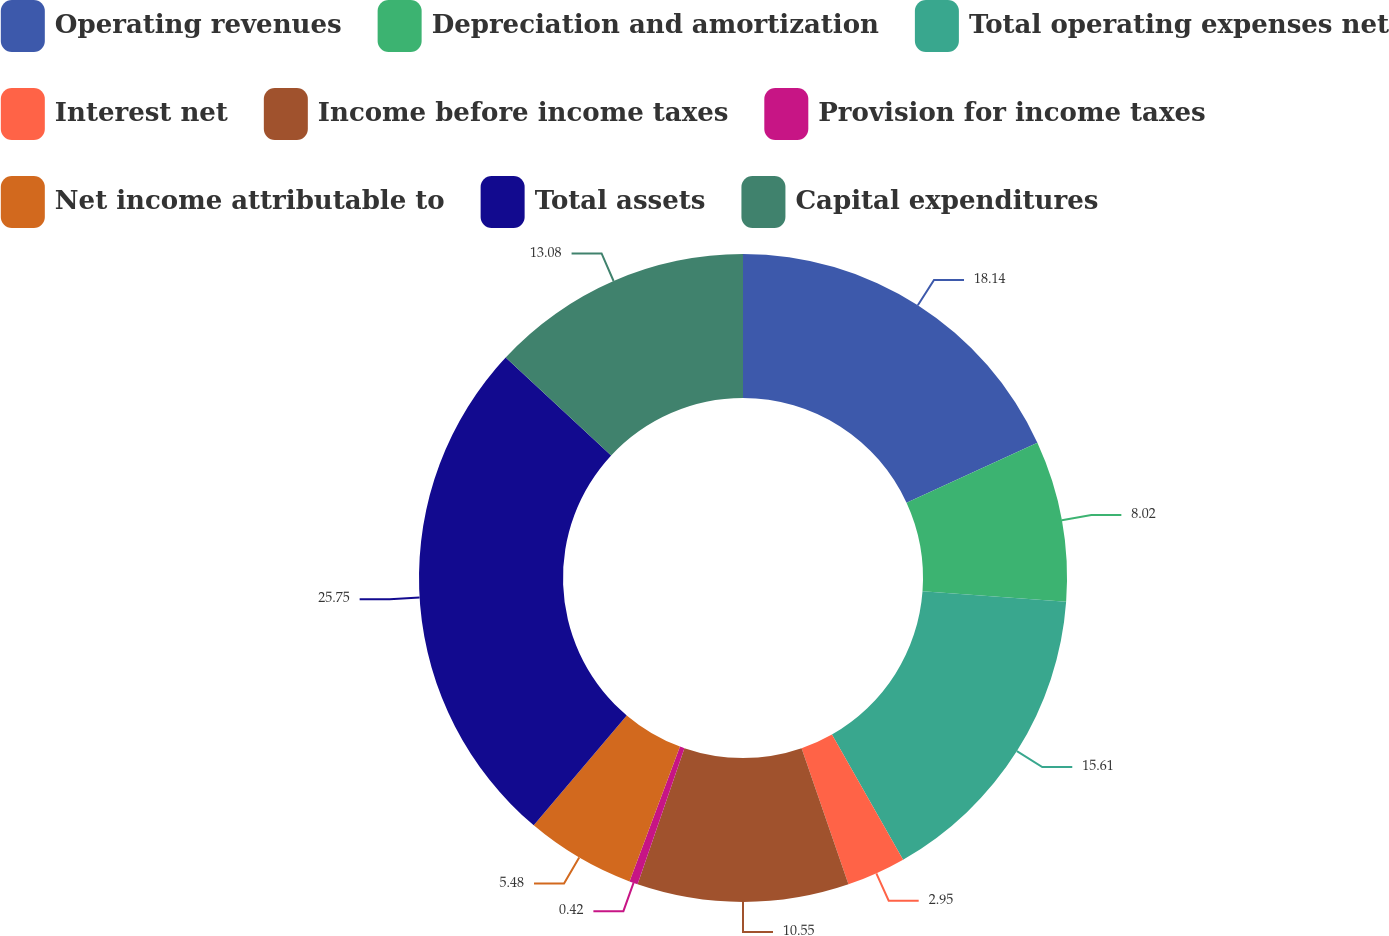<chart> <loc_0><loc_0><loc_500><loc_500><pie_chart><fcel>Operating revenues<fcel>Depreciation and amortization<fcel>Total operating expenses net<fcel>Interest net<fcel>Income before income taxes<fcel>Provision for income taxes<fcel>Net income attributable to<fcel>Total assets<fcel>Capital expenditures<nl><fcel>18.14%<fcel>8.02%<fcel>15.61%<fcel>2.95%<fcel>10.55%<fcel>0.42%<fcel>5.48%<fcel>25.74%<fcel>13.08%<nl></chart> 